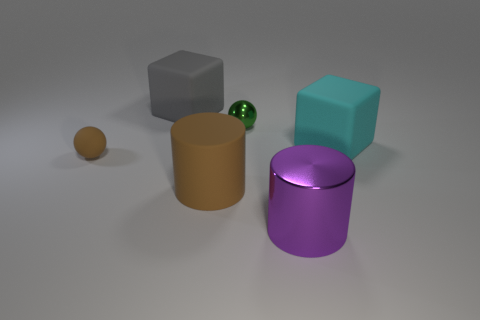Add 4 green metal objects. How many objects exist? 10 Subtract all cylinders. How many objects are left? 4 Subtract 1 cylinders. How many cylinders are left? 1 Add 2 brown rubber cylinders. How many brown rubber cylinders are left? 3 Add 5 purple matte objects. How many purple matte objects exist? 5 Subtract all purple cylinders. How many cylinders are left? 1 Subtract 0 purple spheres. How many objects are left? 6 Subtract all brown cylinders. Subtract all red blocks. How many cylinders are left? 1 Subtract all green cubes. How many brown cylinders are left? 1 Subtract all big metal cylinders. Subtract all big metallic things. How many objects are left? 4 